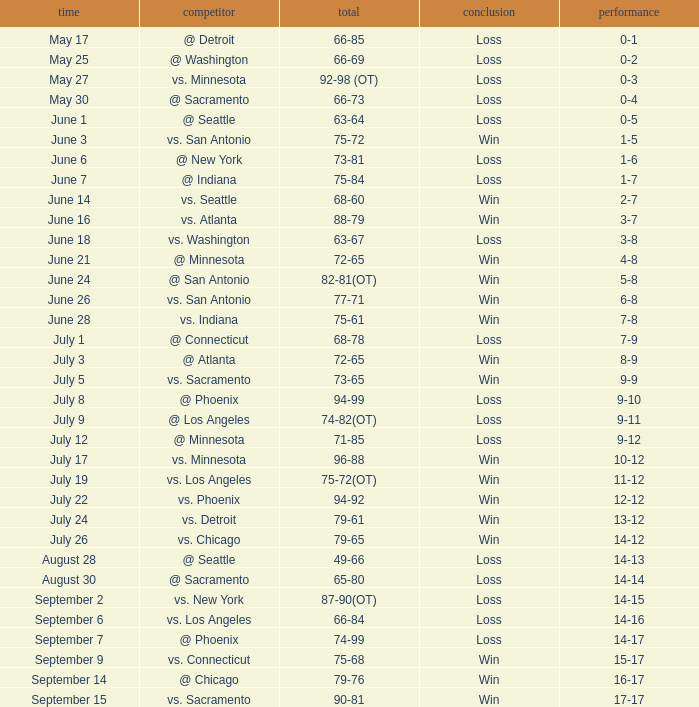What is the Date of the game with a Loss and Record of 7-9? July 1. 